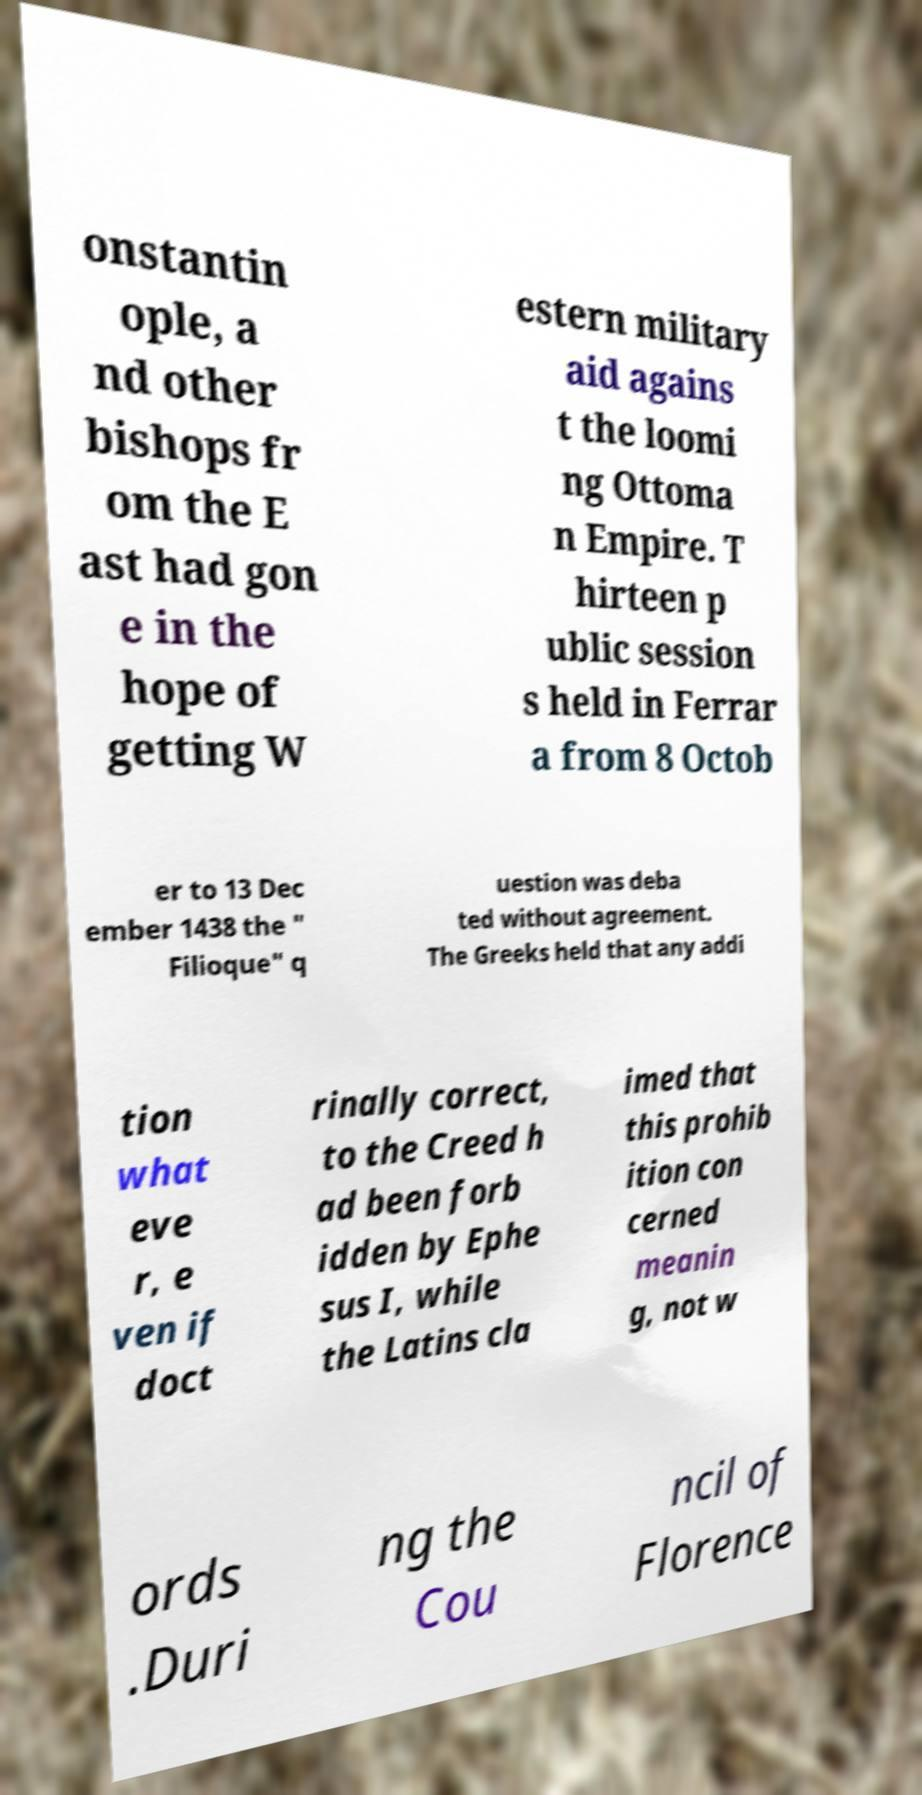What messages or text are displayed in this image? I need them in a readable, typed format. onstantin ople, a nd other bishops fr om the E ast had gon e in the hope of getting W estern military aid agains t the loomi ng Ottoma n Empire. T hirteen p ublic session s held in Ferrar a from 8 Octob er to 13 Dec ember 1438 the " Filioque" q uestion was deba ted without agreement. The Greeks held that any addi tion what eve r, e ven if doct rinally correct, to the Creed h ad been forb idden by Ephe sus I, while the Latins cla imed that this prohib ition con cerned meanin g, not w ords .Duri ng the Cou ncil of Florence 